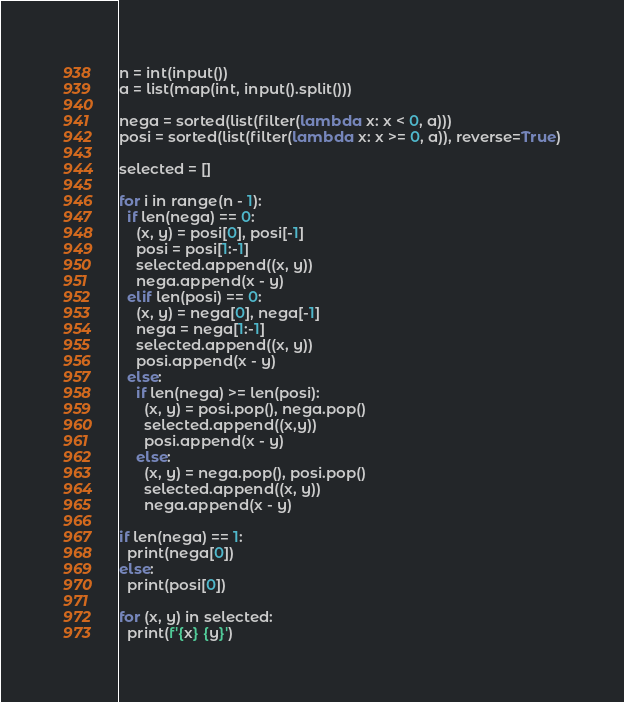<code> <loc_0><loc_0><loc_500><loc_500><_Python_>n = int(input())
a = list(map(int, input().split()))

nega = sorted(list(filter(lambda x: x < 0, a)))
posi = sorted(list(filter(lambda x: x >= 0, a)), reverse=True)

selected = []

for i in range(n - 1):
  if len(nega) == 0:
    (x, y) = posi[0], posi[-1]
    posi = posi[1:-1]
    selected.append((x, y))
    nega.append(x - y)
  elif len(posi) == 0:
    (x, y) = nega[0], nega[-1]
    nega = nega[1:-1]
    selected.append((x, y))
    posi.append(x - y)
  else:
    if len(nega) >= len(posi):
      (x, y) = posi.pop(), nega.pop()
      selected.append((x,y))
      posi.append(x - y)
    else:
      (x, y) = nega.pop(), posi.pop()
      selected.append((x, y))
      nega.append(x - y)

if len(nega) == 1:
  print(nega[0])
else:
  print(posi[0])

for (x, y) in selected:
  print(f'{x} {y}')
</code> 